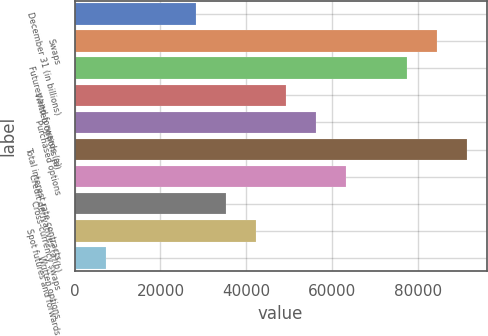Convert chart to OTSL. <chart><loc_0><loc_0><loc_500><loc_500><bar_chart><fcel>December 31 (in billions)<fcel>Swaps<fcel>Futures and forwards (a)<fcel>Written options (a)<fcel>Purchased options<fcel>Total interest rate contracts<fcel>Credit derivatives (a)(b)<fcel>Cross-currency swaps<fcel>Spot futures and forwards<fcel>Written options<nl><fcel>28277.4<fcel>84458.2<fcel>77435.6<fcel>49345.2<fcel>56367.8<fcel>91480.8<fcel>63390.4<fcel>35300<fcel>42322.6<fcel>7209.6<nl></chart> 